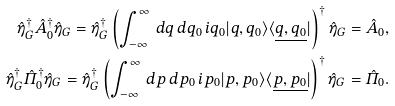Convert formula to latex. <formula><loc_0><loc_0><loc_500><loc_500>\hat { \eta } _ { G } ^ { \dagger } \hat { A } _ { 0 } ^ { \dagger } \hat { \eta } _ { G } = \hat { \eta } _ { G } ^ { \dagger } \left ( \int _ { - \infty } ^ { \infty } \, d q \, d q _ { 0 } \, i q _ { 0 } | { q , q _ { 0 } } \rangle \langle \underline { q , q _ { 0 } } | \right ) ^ { \dagger } \hat { \eta } _ { G } = \hat { A } _ { 0 } , \\ \hat { \eta } _ { G } ^ { \dagger } \hat { \varPi } _ { 0 } ^ { \dagger } \hat { \eta } _ { G } = \hat { \eta } _ { G } ^ { \dagger } \left ( \int _ { - \infty } ^ { \infty } \, d p \, d p _ { 0 } \, i p _ { 0 } | { p , p _ { 0 } } \rangle \langle \underline { p , p _ { 0 } } | \right ) ^ { \dagger } \hat { \eta } _ { G } = \hat { \varPi } _ { 0 } .</formula> 